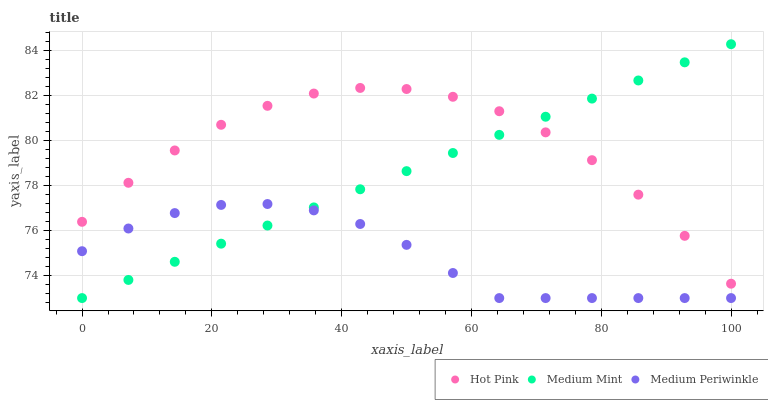Does Medium Periwinkle have the minimum area under the curve?
Answer yes or no. Yes. Does Hot Pink have the maximum area under the curve?
Answer yes or no. Yes. Does Hot Pink have the minimum area under the curve?
Answer yes or no. No. Does Medium Periwinkle have the maximum area under the curve?
Answer yes or no. No. Is Medium Mint the smoothest?
Answer yes or no. Yes. Is Hot Pink the roughest?
Answer yes or no. Yes. Is Medium Periwinkle the smoothest?
Answer yes or no. No. Is Medium Periwinkle the roughest?
Answer yes or no. No. Does Medium Mint have the lowest value?
Answer yes or no. Yes. Does Hot Pink have the lowest value?
Answer yes or no. No. Does Medium Mint have the highest value?
Answer yes or no. Yes. Does Hot Pink have the highest value?
Answer yes or no. No. Is Medium Periwinkle less than Hot Pink?
Answer yes or no. Yes. Is Hot Pink greater than Medium Periwinkle?
Answer yes or no. Yes. Does Medium Mint intersect Hot Pink?
Answer yes or no. Yes. Is Medium Mint less than Hot Pink?
Answer yes or no. No. Is Medium Mint greater than Hot Pink?
Answer yes or no. No. Does Medium Periwinkle intersect Hot Pink?
Answer yes or no. No. 